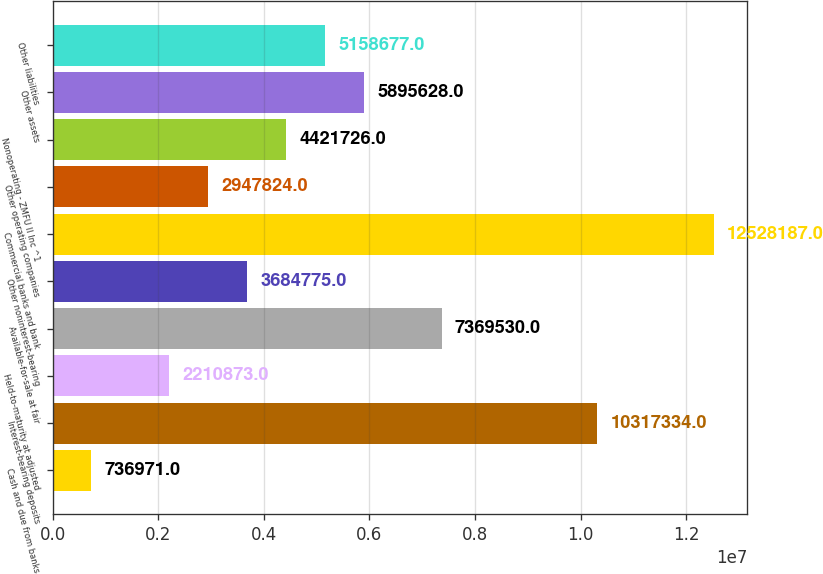<chart> <loc_0><loc_0><loc_500><loc_500><bar_chart><fcel>Cash and due from banks<fcel>Interest-bearing deposits<fcel>Held-to-maturity at adjusted<fcel>Available-for-sale at fair<fcel>Other noninterest-bearing<fcel>Commercial banks and bank<fcel>Other operating companies<fcel>Nonoperating - ZMFU II Inc ^1<fcel>Other assets<fcel>Other liabilities<nl><fcel>736971<fcel>1.03173e+07<fcel>2.21087e+06<fcel>7.36953e+06<fcel>3.68478e+06<fcel>1.25282e+07<fcel>2.94782e+06<fcel>4.42173e+06<fcel>5.89563e+06<fcel>5.15868e+06<nl></chart> 